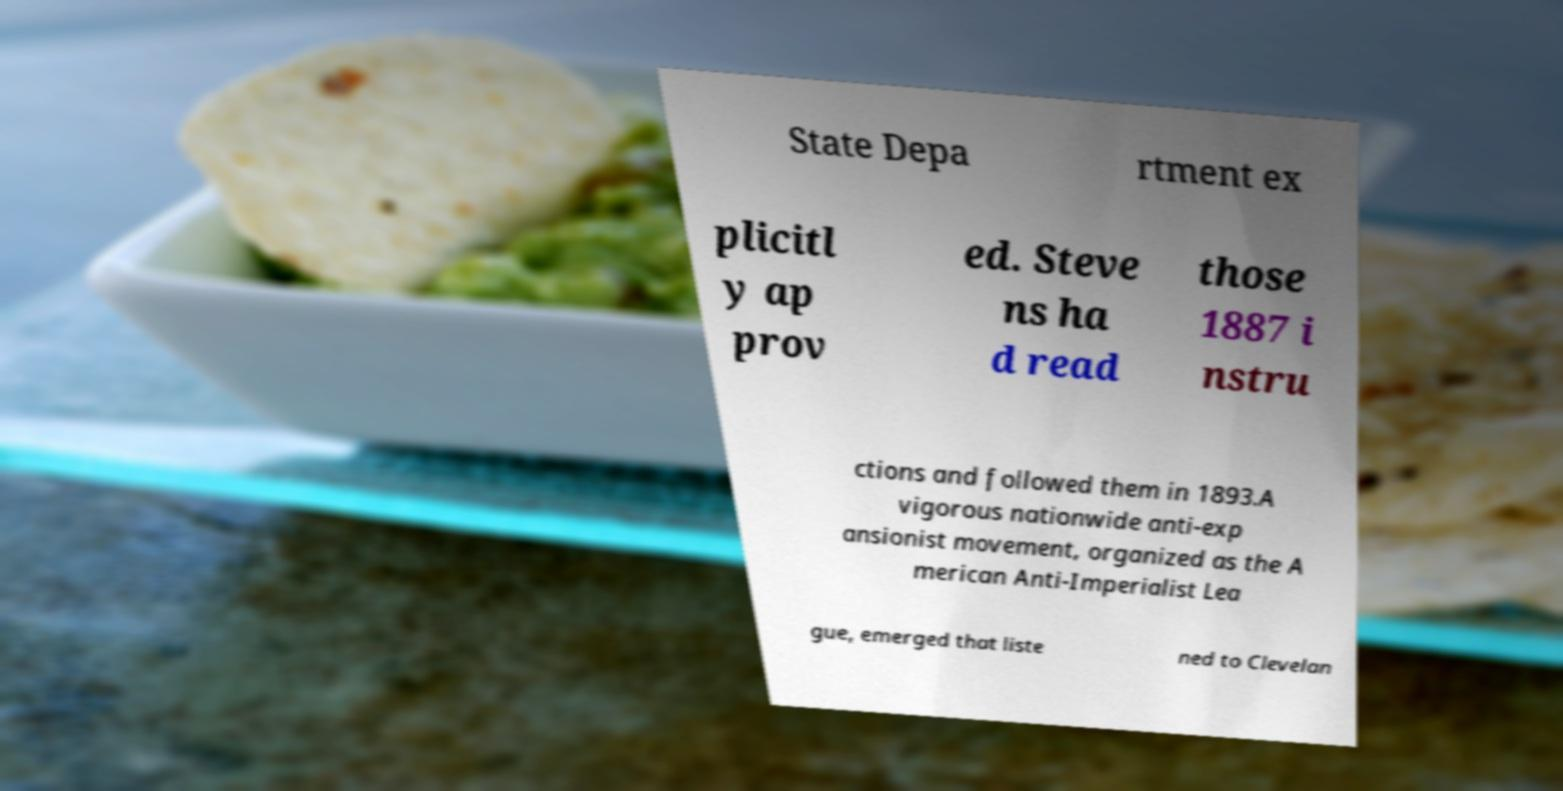Could you extract and type out the text from this image? State Depa rtment ex plicitl y ap prov ed. Steve ns ha d read those 1887 i nstru ctions and followed them in 1893.A vigorous nationwide anti-exp ansionist movement, organized as the A merican Anti-Imperialist Lea gue, emerged that liste ned to Clevelan 